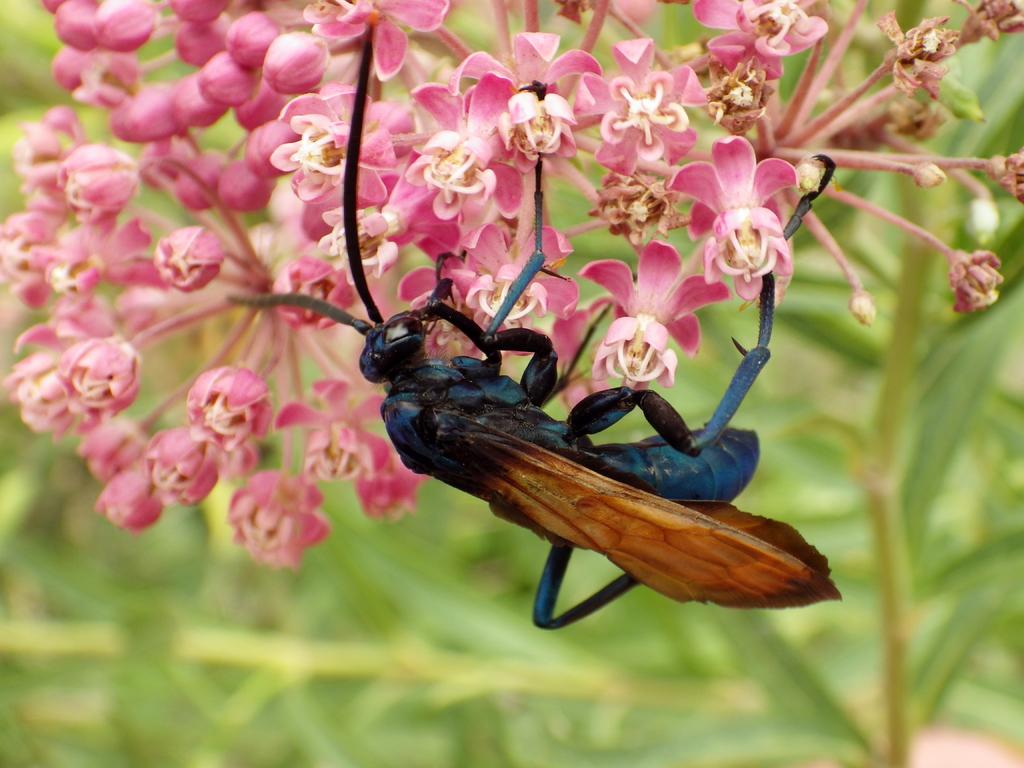What type of flower can be seen in the image? There is a pink color flower in the image. Is there any other living organism present on the flower? Yes, there is a black and brown color insect on the flower. What can be seen in the background of the image? There is greenery in the background of the image. What type of metal is used to create the fictional sorting hat in the image? There is no sorting hat or metal present in the image; it features a pink flower with an insect on it and greenery in the background. 